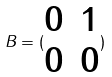<formula> <loc_0><loc_0><loc_500><loc_500>B = ( \begin{matrix} 0 & 1 \\ 0 & 0 \end{matrix} )</formula> 